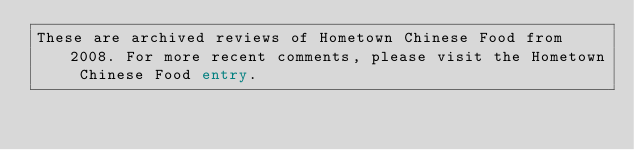<code> <loc_0><loc_0><loc_500><loc_500><_FORTRAN_>These are archived reviews of Hometown Chinese Food from 2008. For more recent comments, please visit the Hometown Chinese Food entry.

</code> 